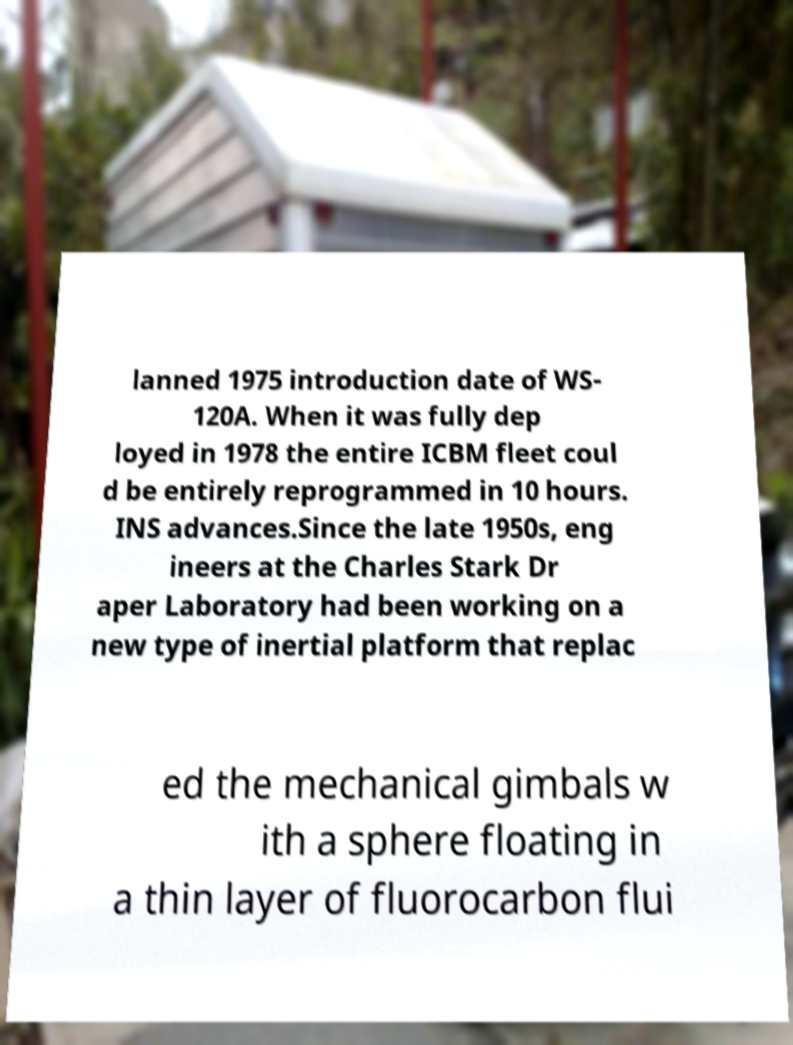There's text embedded in this image that I need extracted. Can you transcribe it verbatim? lanned 1975 introduction date of WS- 120A. When it was fully dep loyed in 1978 the entire ICBM fleet coul d be entirely reprogrammed in 10 hours. INS advances.Since the late 1950s, eng ineers at the Charles Stark Dr aper Laboratory had been working on a new type of inertial platform that replac ed the mechanical gimbals w ith a sphere floating in a thin layer of fluorocarbon flui 